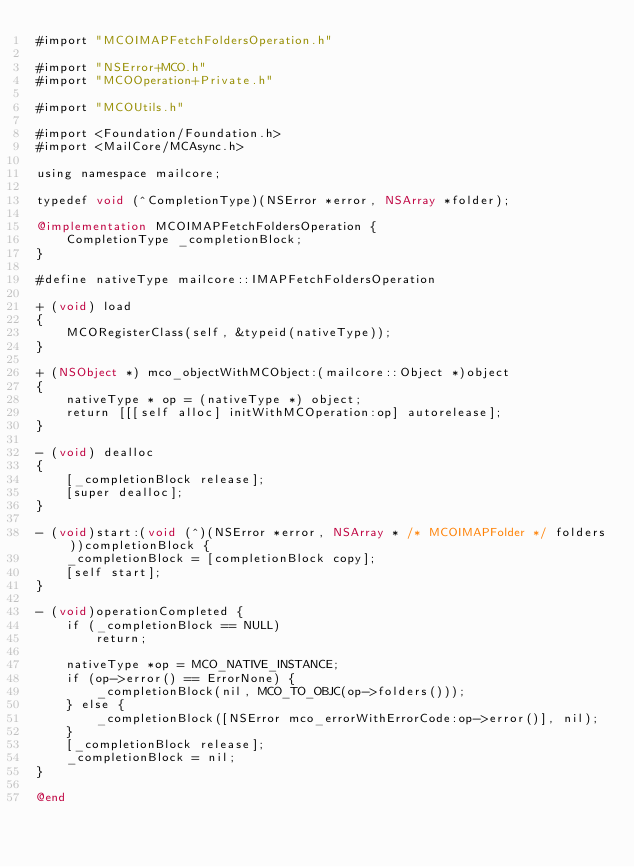<code> <loc_0><loc_0><loc_500><loc_500><_ObjectiveC_>#import "MCOIMAPFetchFoldersOperation.h"

#import "NSError+MCO.h"
#import "MCOOperation+Private.h"

#import "MCOUtils.h"

#import <Foundation/Foundation.h>
#import <MailCore/MCAsync.h>

using namespace mailcore;

typedef void (^CompletionType)(NSError *error, NSArray *folder);

@implementation MCOIMAPFetchFoldersOperation {
    CompletionType _completionBlock;
}

#define nativeType mailcore::IMAPFetchFoldersOperation

+ (void) load
{
    MCORegisterClass(self, &typeid(nativeType));
}

+ (NSObject *) mco_objectWithMCObject:(mailcore::Object *)object
{
    nativeType * op = (nativeType *) object;
    return [[[self alloc] initWithMCOperation:op] autorelease];
}

- (void) dealloc
{
    [_completionBlock release];
    [super dealloc];
}

- (void)start:(void (^)(NSError *error, NSArray * /* MCOIMAPFolder */ folders))completionBlock {
    _completionBlock = [completionBlock copy];
    [self start];
}

- (void)operationCompleted {
    if (_completionBlock == NULL)
        return;
    
    nativeType *op = MCO_NATIVE_INSTANCE;
    if (op->error() == ErrorNone) {
        _completionBlock(nil, MCO_TO_OBJC(op->folders()));
    } else {
        _completionBlock([NSError mco_errorWithErrorCode:op->error()], nil);
    }
    [_completionBlock release];
    _completionBlock = nil;
}

@end
</code> 